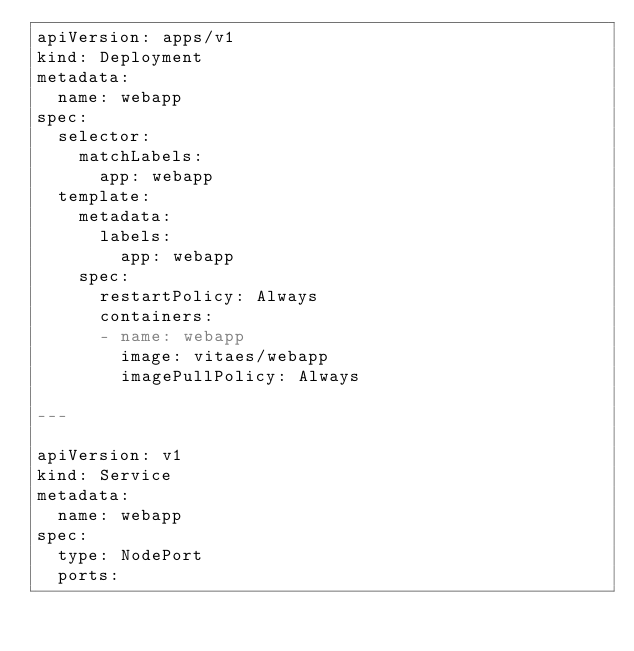<code> <loc_0><loc_0><loc_500><loc_500><_YAML_>apiVersion: apps/v1
kind: Deployment
metadata:
  name: webapp
spec:
  selector:
    matchLabels:
      app: webapp
  template:
    metadata:
      labels:
        app: webapp
    spec:
      restartPolicy: Always
      containers:
      - name: webapp
        image: vitaes/webapp
        imagePullPolicy: Always

---

apiVersion: v1
kind: Service
metadata:
  name: webapp
spec:
  type: NodePort
  ports:</code> 